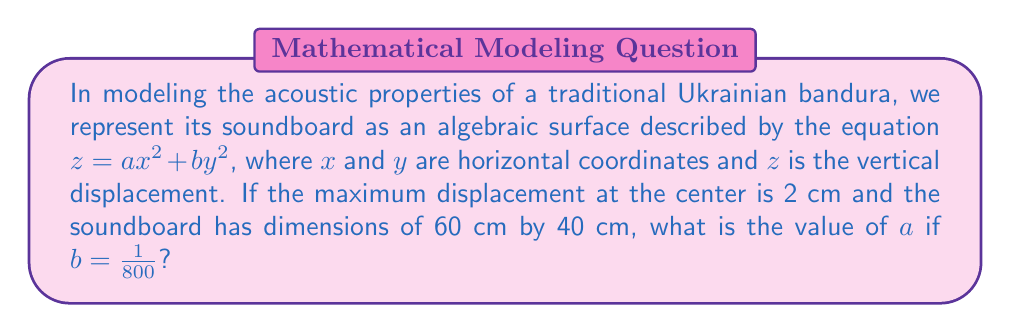Solve this math problem. Let's approach this step-by-step:

1) The equation of the surface is $z = ax^2 + by^2$

2) We're given that $b = \frac{1}{800}$

3) The maximum displacement is at the center (0, 0) and equals 2 cm. So:

   $2 = a(0)^2 + \frac{1}{800}(0)^2 = 0$

   This doesn't give us any information about $a$.

4) The dimensions of the soundboard are 60 cm by 40 cm. Let's assume the origin is at the center, so x ranges from -30 to 30, and y from -20 to 20.

5) At the edge of the soundboard, z should be 0. Let's use the point (30, 20):

   $0 = a(30)^2 + \frac{1}{800}(20)^2$

6) Simplify:

   $0 = 900a + \frac{400}{800} = 900a + \frac{1}{2}$

7) Solve for $a$:

   $900a = -\frac{1}{2}$
   $a = -\frac{1}{1800}$

Therefore, the value of $a$ is $-\frac{1}{1800}$.
Answer: $-\frac{1}{1800}$ 